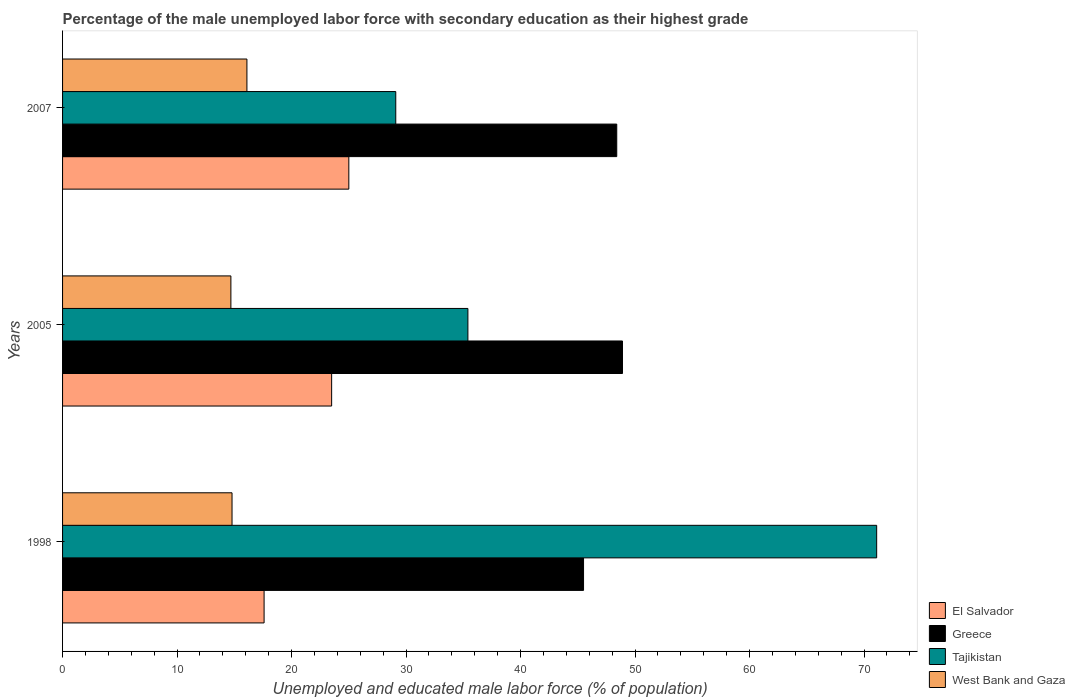Are the number of bars per tick equal to the number of legend labels?
Provide a short and direct response. Yes. Are the number of bars on each tick of the Y-axis equal?
Keep it short and to the point. Yes. How many bars are there on the 3rd tick from the top?
Offer a very short reply. 4. How many bars are there on the 2nd tick from the bottom?
Ensure brevity in your answer.  4. What is the label of the 1st group of bars from the top?
Offer a very short reply. 2007. In how many cases, is the number of bars for a given year not equal to the number of legend labels?
Provide a short and direct response. 0. What is the percentage of the unemployed male labor force with secondary education in Greece in 1998?
Provide a short and direct response. 45.5. Across all years, what is the maximum percentage of the unemployed male labor force with secondary education in West Bank and Gaza?
Provide a short and direct response. 16.1. Across all years, what is the minimum percentage of the unemployed male labor force with secondary education in Greece?
Keep it short and to the point. 45.5. What is the total percentage of the unemployed male labor force with secondary education in El Salvador in the graph?
Offer a very short reply. 66.1. What is the difference between the percentage of the unemployed male labor force with secondary education in Greece in 1998 and that in 2005?
Ensure brevity in your answer.  -3.4. What is the difference between the percentage of the unemployed male labor force with secondary education in West Bank and Gaza in 2007 and the percentage of the unemployed male labor force with secondary education in Tajikistan in 1998?
Your response must be concise. -55. What is the average percentage of the unemployed male labor force with secondary education in Greece per year?
Offer a terse response. 47.6. In the year 2007, what is the difference between the percentage of the unemployed male labor force with secondary education in El Salvador and percentage of the unemployed male labor force with secondary education in Greece?
Your answer should be compact. -23.4. What is the ratio of the percentage of the unemployed male labor force with secondary education in Tajikistan in 2005 to that in 2007?
Ensure brevity in your answer.  1.22. Is the difference between the percentage of the unemployed male labor force with secondary education in El Salvador in 2005 and 2007 greater than the difference between the percentage of the unemployed male labor force with secondary education in Greece in 2005 and 2007?
Your answer should be compact. No. What is the difference between the highest and the second highest percentage of the unemployed male labor force with secondary education in Tajikistan?
Give a very brief answer. 35.7. What is the difference between the highest and the lowest percentage of the unemployed male labor force with secondary education in Greece?
Give a very brief answer. 3.4. In how many years, is the percentage of the unemployed male labor force with secondary education in Greece greater than the average percentage of the unemployed male labor force with secondary education in Greece taken over all years?
Your response must be concise. 2. What does the 1st bar from the top in 1998 represents?
Make the answer very short. West Bank and Gaza. What does the 3rd bar from the bottom in 1998 represents?
Provide a succinct answer. Tajikistan. Is it the case that in every year, the sum of the percentage of the unemployed male labor force with secondary education in Greece and percentage of the unemployed male labor force with secondary education in West Bank and Gaza is greater than the percentage of the unemployed male labor force with secondary education in Tajikistan?
Your response must be concise. No. How many bars are there?
Your answer should be very brief. 12. What is the difference between two consecutive major ticks on the X-axis?
Your answer should be compact. 10. Does the graph contain any zero values?
Keep it short and to the point. No. What is the title of the graph?
Your answer should be compact. Percentage of the male unemployed labor force with secondary education as their highest grade. What is the label or title of the X-axis?
Provide a succinct answer. Unemployed and educated male labor force (% of population). What is the Unemployed and educated male labor force (% of population) of El Salvador in 1998?
Give a very brief answer. 17.6. What is the Unemployed and educated male labor force (% of population) in Greece in 1998?
Your answer should be compact. 45.5. What is the Unemployed and educated male labor force (% of population) of Tajikistan in 1998?
Offer a terse response. 71.1. What is the Unemployed and educated male labor force (% of population) of West Bank and Gaza in 1998?
Your answer should be compact. 14.8. What is the Unemployed and educated male labor force (% of population) of El Salvador in 2005?
Provide a succinct answer. 23.5. What is the Unemployed and educated male labor force (% of population) in Greece in 2005?
Your response must be concise. 48.9. What is the Unemployed and educated male labor force (% of population) in Tajikistan in 2005?
Your answer should be very brief. 35.4. What is the Unemployed and educated male labor force (% of population) in West Bank and Gaza in 2005?
Provide a succinct answer. 14.7. What is the Unemployed and educated male labor force (% of population) in El Salvador in 2007?
Offer a very short reply. 25. What is the Unemployed and educated male labor force (% of population) of Greece in 2007?
Provide a succinct answer. 48.4. What is the Unemployed and educated male labor force (% of population) of Tajikistan in 2007?
Your answer should be compact. 29.1. What is the Unemployed and educated male labor force (% of population) in West Bank and Gaza in 2007?
Offer a very short reply. 16.1. Across all years, what is the maximum Unemployed and educated male labor force (% of population) in El Salvador?
Your answer should be very brief. 25. Across all years, what is the maximum Unemployed and educated male labor force (% of population) of Greece?
Offer a very short reply. 48.9. Across all years, what is the maximum Unemployed and educated male labor force (% of population) in Tajikistan?
Provide a succinct answer. 71.1. Across all years, what is the maximum Unemployed and educated male labor force (% of population) of West Bank and Gaza?
Your answer should be very brief. 16.1. Across all years, what is the minimum Unemployed and educated male labor force (% of population) in El Salvador?
Offer a terse response. 17.6. Across all years, what is the minimum Unemployed and educated male labor force (% of population) of Greece?
Your response must be concise. 45.5. Across all years, what is the minimum Unemployed and educated male labor force (% of population) in Tajikistan?
Keep it short and to the point. 29.1. Across all years, what is the minimum Unemployed and educated male labor force (% of population) in West Bank and Gaza?
Offer a very short reply. 14.7. What is the total Unemployed and educated male labor force (% of population) in El Salvador in the graph?
Your answer should be very brief. 66.1. What is the total Unemployed and educated male labor force (% of population) in Greece in the graph?
Ensure brevity in your answer.  142.8. What is the total Unemployed and educated male labor force (% of population) of Tajikistan in the graph?
Your answer should be compact. 135.6. What is the total Unemployed and educated male labor force (% of population) of West Bank and Gaza in the graph?
Give a very brief answer. 45.6. What is the difference between the Unemployed and educated male labor force (% of population) in Tajikistan in 1998 and that in 2005?
Your response must be concise. 35.7. What is the difference between the Unemployed and educated male labor force (% of population) of Greece in 1998 and that in 2007?
Your answer should be very brief. -2.9. What is the difference between the Unemployed and educated male labor force (% of population) of El Salvador in 2005 and that in 2007?
Give a very brief answer. -1.5. What is the difference between the Unemployed and educated male labor force (% of population) in El Salvador in 1998 and the Unemployed and educated male labor force (% of population) in Greece in 2005?
Keep it short and to the point. -31.3. What is the difference between the Unemployed and educated male labor force (% of population) in El Salvador in 1998 and the Unemployed and educated male labor force (% of population) in Tajikistan in 2005?
Offer a terse response. -17.8. What is the difference between the Unemployed and educated male labor force (% of population) of Greece in 1998 and the Unemployed and educated male labor force (% of population) of Tajikistan in 2005?
Offer a very short reply. 10.1. What is the difference between the Unemployed and educated male labor force (% of population) of Greece in 1998 and the Unemployed and educated male labor force (% of population) of West Bank and Gaza in 2005?
Give a very brief answer. 30.8. What is the difference between the Unemployed and educated male labor force (% of population) in Tajikistan in 1998 and the Unemployed and educated male labor force (% of population) in West Bank and Gaza in 2005?
Your answer should be very brief. 56.4. What is the difference between the Unemployed and educated male labor force (% of population) in El Salvador in 1998 and the Unemployed and educated male labor force (% of population) in Greece in 2007?
Provide a short and direct response. -30.8. What is the difference between the Unemployed and educated male labor force (% of population) of Greece in 1998 and the Unemployed and educated male labor force (% of population) of West Bank and Gaza in 2007?
Keep it short and to the point. 29.4. What is the difference between the Unemployed and educated male labor force (% of population) of El Salvador in 2005 and the Unemployed and educated male labor force (% of population) of Greece in 2007?
Your answer should be very brief. -24.9. What is the difference between the Unemployed and educated male labor force (% of population) in El Salvador in 2005 and the Unemployed and educated male labor force (% of population) in West Bank and Gaza in 2007?
Make the answer very short. 7.4. What is the difference between the Unemployed and educated male labor force (% of population) of Greece in 2005 and the Unemployed and educated male labor force (% of population) of Tajikistan in 2007?
Keep it short and to the point. 19.8. What is the difference between the Unemployed and educated male labor force (% of population) of Greece in 2005 and the Unemployed and educated male labor force (% of population) of West Bank and Gaza in 2007?
Give a very brief answer. 32.8. What is the difference between the Unemployed and educated male labor force (% of population) of Tajikistan in 2005 and the Unemployed and educated male labor force (% of population) of West Bank and Gaza in 2007?
Provide a succinct answer. 19.3. What is the average Unemployed and educated male labor force (% of population) of El Salvador per year?
Your response must be concise. 22.03. What is the average Unemployed and educated male labor force (% of population) of Greece per year?
Your answer should be compact. 47.6. What is the average Unemployed and educated male labor force (% of population) in Tajikistan per year?
Your response must be concise. 45.2. In the year 1998, what is the difference between the Unemployed and educated male labor force (% of population) of El Salvador and Unemployed and educated male labor force (% of population) of Greece?
Offer a terse response. -27.9. In the year 1998, what is the difference between the Unemployed and educated male labor force (% of population) of El Salvador and Unemployed and educated male labor force (% of population) of Tajikistan?
Offer a terse response. -53.5. In the year 1998, what is the difference between the Unemployed and educated male labor force (% of population) of Greece and Unemployed and educated male labor force (% of population) of Tajikistan?
Your answer should be very brief. -25.6. In the year 1998, what is the difference between the Unemployed and educated male labor force (% of population) of Greece and Unemployed and educated male labor force (% of population) of West Bank and Gaza?
Make the answer very short. 30.7. In the year 1998, what is the difference between the Unemployed and educated male labor force (% of population) of Tajikistan and Unemployed and educated male labor force (% of population) of West Bank and Gaza?
Your response must be concise. 56.3. In the year 2005, what is the difference between the Unemployed and educated male labor force (% of population) in El Salvador and Unemployed and educated male labor force (% of population) in Greece?
Offer a terse response. -25.4. In the year 2005, what is the difference between the Unemployed and educated male labor force (% of population) in El Salvador and Unemployed and educated male labor force (% of population) in Tajikistan?
Ensure brevity in your answer.  -11.9. In the year 2005, what is the difference between the Unemployed and educated male labor force (% of population) of Greece and Unemployed and educated male labor force (% of population) of Tajikistan?
Make the answer very short. 13.5. In the year 2005, what is the difference between the Unemployed and educated male labor force (% of population) of Greece and Unemployed and educated male labor force (% of population) of West Bank and Gaza?
Ensure brevity in your answer.  34.2. In the year 2005, what is the difference between the Unemployed and educated male labor force (% of population) of Tajikistan and Unemployed and educated male labor force (% of population) of West Bank and Gaza?
Your answer should be compact. 20.7. In the year 2007, what is the difference between the Unemployed and educated male labor force (% of population) in El Salvador and Unemployed and educated male labor force (% of population) in Greece?
Keep it short and to the point. -23.4. In the year 2007, what is the difference between the Unemployed and educated male labor force (% of population) of El Salvador and Unemployed and educated male labor force (% of population) of Tajikistan?
Offer a terse response. -4.1. In the year 2007, what is the difference between the Unemployed and educated male labor force (% of population) of El Salvador and Unemployed and educated male labor force (% of population) of West Bank and Gaza?
Your answer should be very brief. 8.9. In the year 2007, what is the difference between the Unemployed and educated male labor force (% of population) in Greece and Unemployed and educated male labor force (% of population) in Tajikistan?
Give a very brief answer. 19.3. In the year 2007, what is the difference between the Unemployed and educated male labor force (% of population) in Greece and Unemployed and educated male labor force (% of population) in West Bank and Gaza?
Ensure brevity in your answer.  32.3. What is the ratio of the Unemployed and educated male labor force (% of population) of El Salvador in 1998 to that in 2005?
Offer a terse response. 0.75. What is the ratio of the Unemployed and educated male labor force (% of population) in Greece in 1998 to that in 2005?
Provide a short and direct response. 0.93. What is the ratio of the Unemployed and educated male labor force (% of population) in Tajikistan in 1998 to that in 2005?
Provide a succinct answer. 2.01. What is the ratio of the Unemployed and educated male labor force (% of population) of West Bank and Gaza in 1998 to that in 2005?
Your answer should be very brief. 1.01. What is the ratio of the Unemployed and educated male labor force (% of population) in El Salvador in 1998 to that in 2007?
Keep it short and to the point. 0.7. What is the ratio of the Unemployed and educated male labor force (% of population) in Greece in 1998 to that in 2007?
Give a very brief answer. 0.94. What is the ratio of the Unemployed and educated male labor force (% of population) in Tajikistan in 1998 to that in 2007?
Keep it short and to the point. 2.44. What is the ratio of the Unemployed and educated male labor force (% of population) of West Bank and Gaza in 1998 to that in 2007?
Your answer should be very brief. 0.92. What is the ratio of the Unemployed and educated male labor force (% of population) of El Salvador in 2005 to that in 2007?
Keep it short and to the point. 0.94. What is the ratio of the Unemployed and educated male labor force (% of population) in Greece in 2005 to that in 2007?
Keep it short and to the point. 1.01. What is the ratio of the Unemployed and educated male labor force (% of population) of Tajikistan in 2005 to that in 2007?
Make the answer very short. 1.22. What is the difference between the highest and the second highest Unemployed and educated male labor force (% of population) in Greece?
Your answer should be compact. 0.5. What is the difference between the highest and the second highest Unemployed and educated male labor force (% of population) in Tajikistan?
Your response must be concise. 35.7. What is the difference between the highest and the second highest Unemployed and educated male labor force (% of population) of West Bank and Gaza?
Give a very brief answer. 1.3. What is the difference between the highest and the lowest Unemployed and educated male labor force (% of population) in Greece?
Provide a short and direct response. 3.4. 